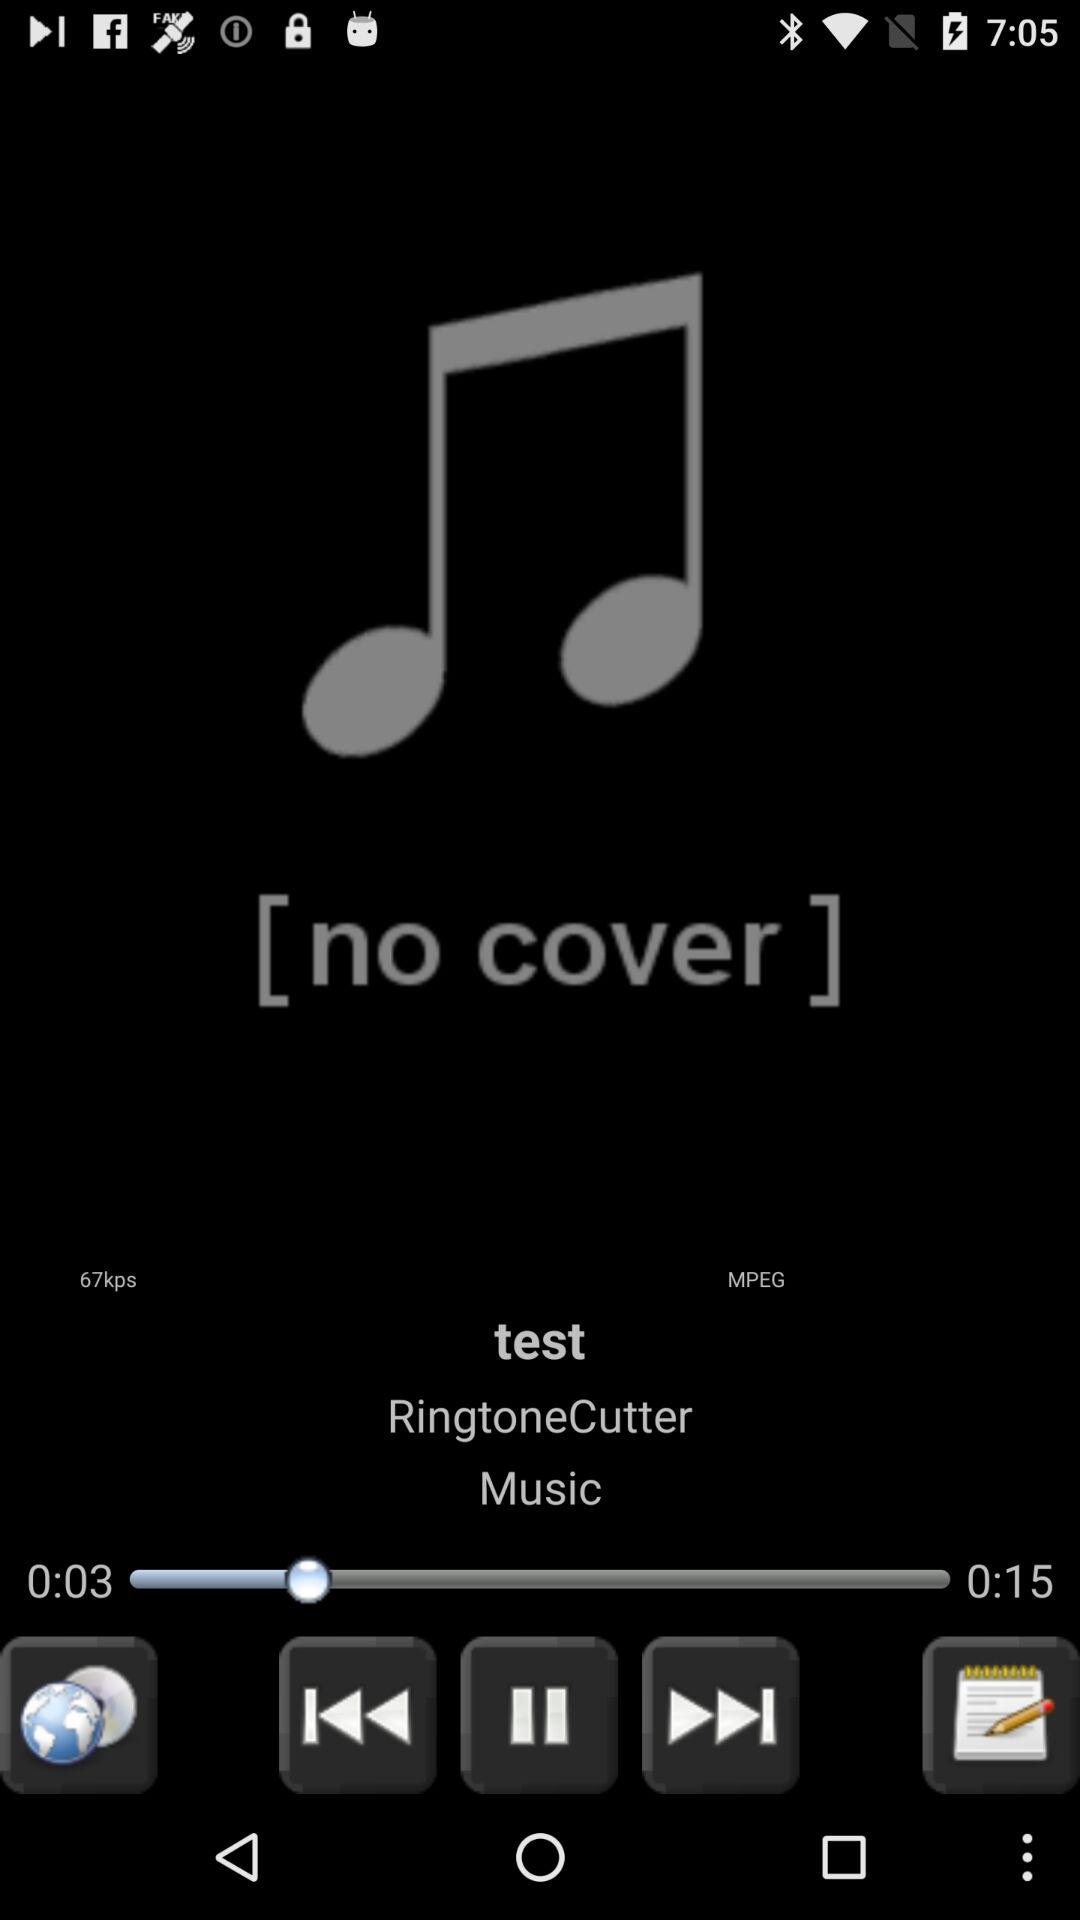What is the name of the song? The name of the song is "test". 